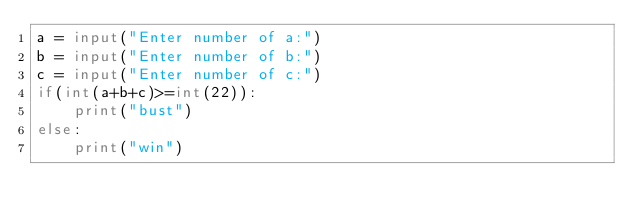Convert code to text. <code><loc_0><loc_0><loc_500><loc_500><_Python_>a = input("Enter number of a:")
b = input("Enter number of b:")
c = input("Enter number of c:")
if(int(a+b+c)>=int(22)):
    print("bust")
else:
    print("win")
</code> 